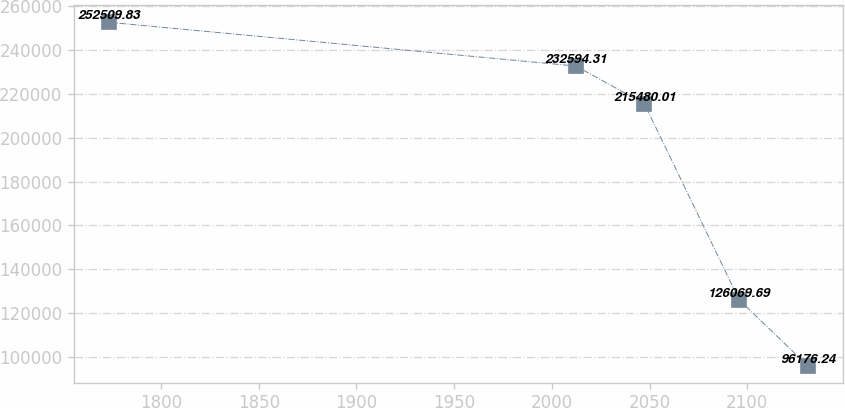<chart> <loc_0><loc_0><loc_500><loc_500><line_chart><ecel><fcel>Unnamed: 1<nl><fcel>1773.36<fcel>252510<nl><fcel>2012.27<fcel>232594<nl><fcel>2047.33<fcel>215480<nl><fcel>2095.89<fcel>126070<nl><fcel>2130.95<fcel>96176.2<nl></chart> 